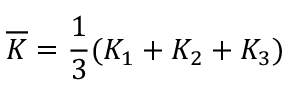<formula> <loc_0><loc_0><loc_500><loc_500>\overline { K } = \frac { 1 } { 3 } ( K _ { 1 } + K _ { 2 } + K _ { 3 } )</formula> 